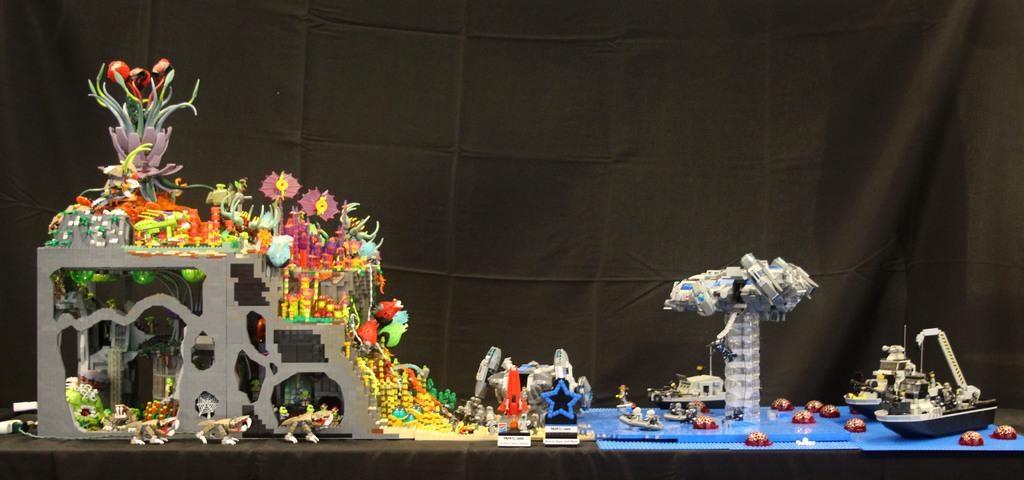What type of objects can be seen in the image? There are toys and miniatures of boats in the image. What kind of plants are present in the image? There are multi-colored flowers in the image. What can be seen in the background of the image? In the background, there are black curtains. Is there a scarecrow involved in an argument in the image? There is no scarecrow or argument present in the image. What is the size of the flowers in the image? The size of the flowers cannot be determined from the image alone, as there is no reference for scale provided. 